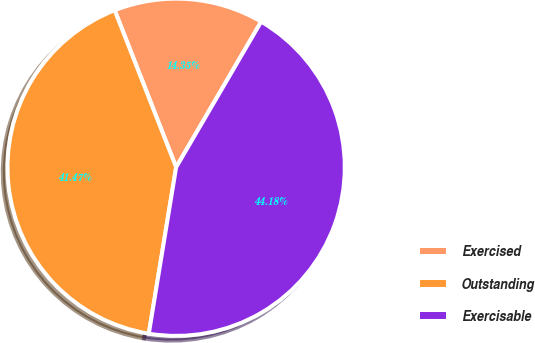Convert chart to OTSL. <chart><loc_0><loc_0><loc_500><loc_500><pie_chart><fcel>Exercised<fcel>Outstanding<fcel>Exercisable<nl><fcel>14.35%<fcel>41.47%<fcel>44.18%<nl></chart> 